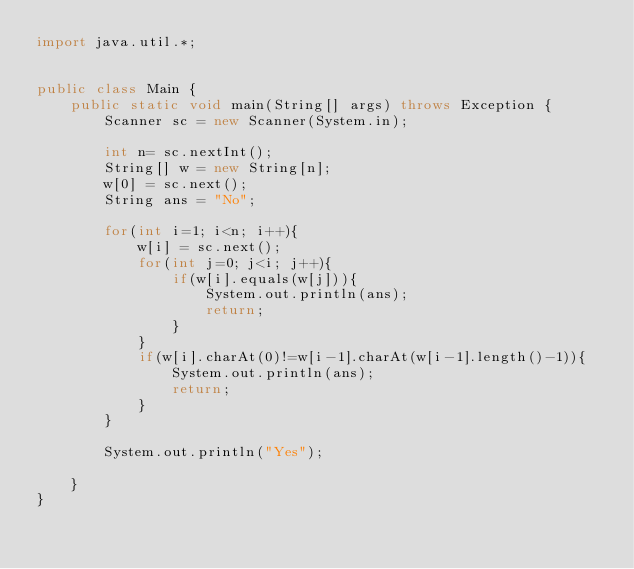<code> <loc_0><loc_0><loc_500><loc_500><_Java_>import java.util.*;


public class Main {
    public static void main(String[] args) throws Exception {
        Scanner sc = new Scanner(System.in);
        
        int n= sc.nextInt();
        String[] w = new String[n];
        w[0] = sc.next();
        String ans = "No";
        
        for(int i=1; i<n; i++){
            w[i] = sc.next();
            for(int j=0; j<i; j++){
                if(w[i].equals(w[j])){
                    System.out.println(ans);
                    return;
                }
            }
            if(w[i].charAt(0)!=w[i-1].charAt(w[i-1].length()-1)){
                System.out.println(ans);
                return;
            }
        }
        
        System.out.println("Yes");
        
	}
}</code> 